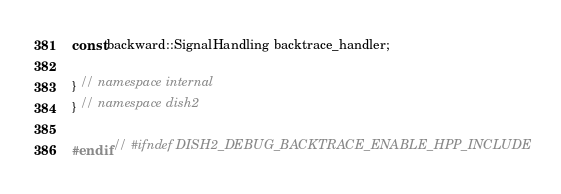Convert code to text. <code><loc_0><loc_0><loc_500><loc_500><_C++_>const backward::SignalHandling backtrace_handler;

} // namespace internal
} // namespace dish2

#endif // #ifndef DISH2_DEBUG_BACKTRACE_ENABLE_HPP_INCLUDE
</code> 